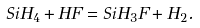Convert formula to latex. <formula><loc_0><loc_0><loc_500><loc_500>S i H _ { 4 } + H F = S i H _ { 3 } F + H _ { 2 } .</formula> 